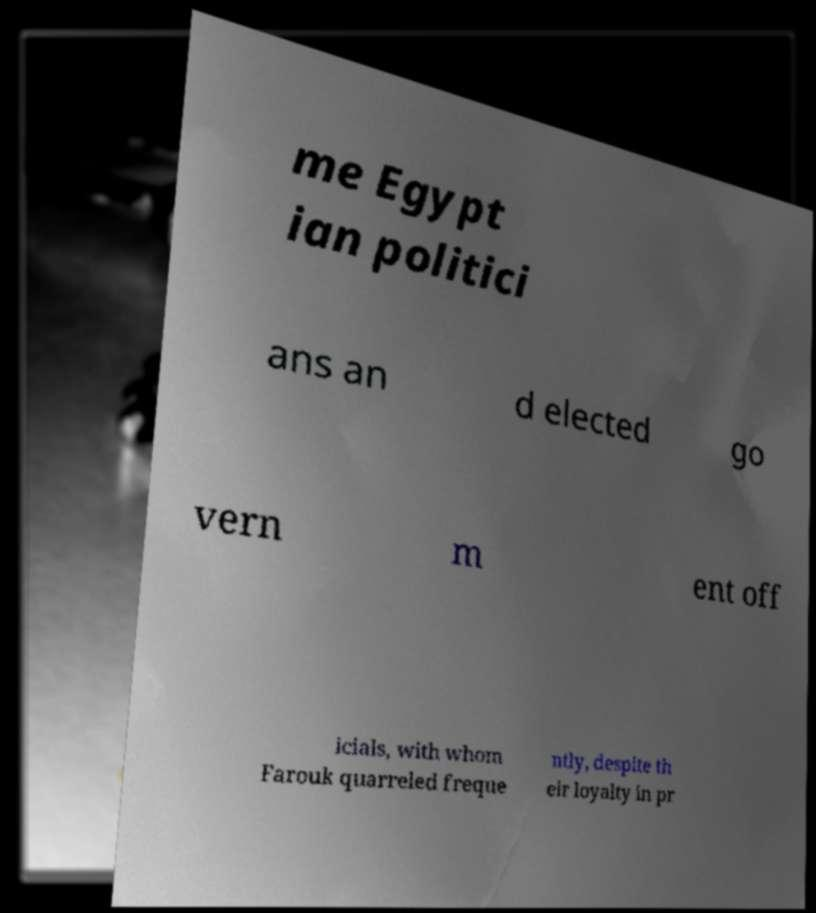Could you extract and type out the text from this image? me Egypt ian politici ans an d elected go vern m ent off icials, with whom Farouk quarreled freque ntly, despite th eir loyalty in pr 